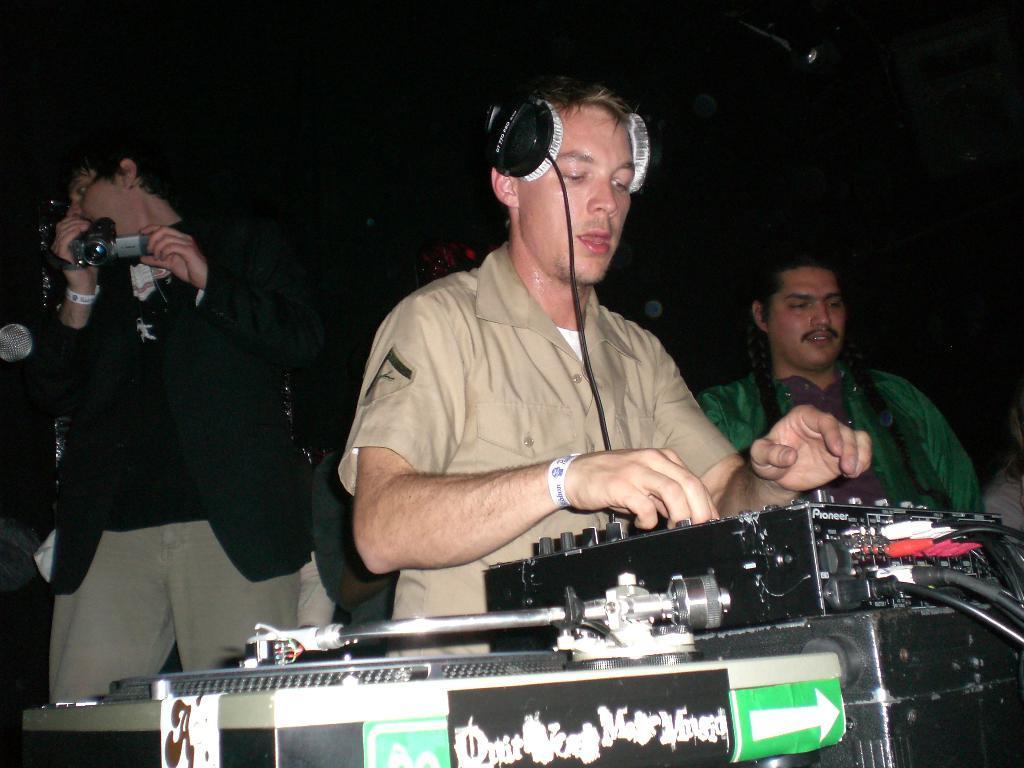Please provide a concise description of this image. In this picture we can see three persons here, there is a music controller here, we can see headphones here, a man on the left side is holding a camera, we can see some wires here. 